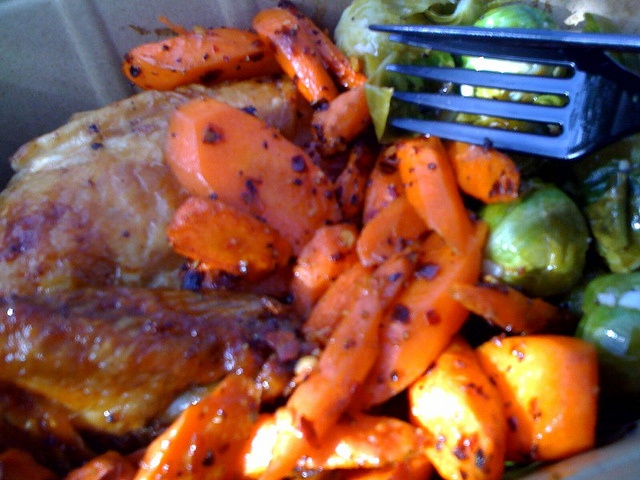Describe the objects in this image and their specific colors. I can see carrot in teal, red, brown, orange, and salmon tones, fork in teal, black, lightblue, navy, and blue tones, carrot in teal, maroon, brown, and salmon tones, carrot in teal, brown, and red tones, and carrot in teal, red, brown, and maroon tones in this image. 